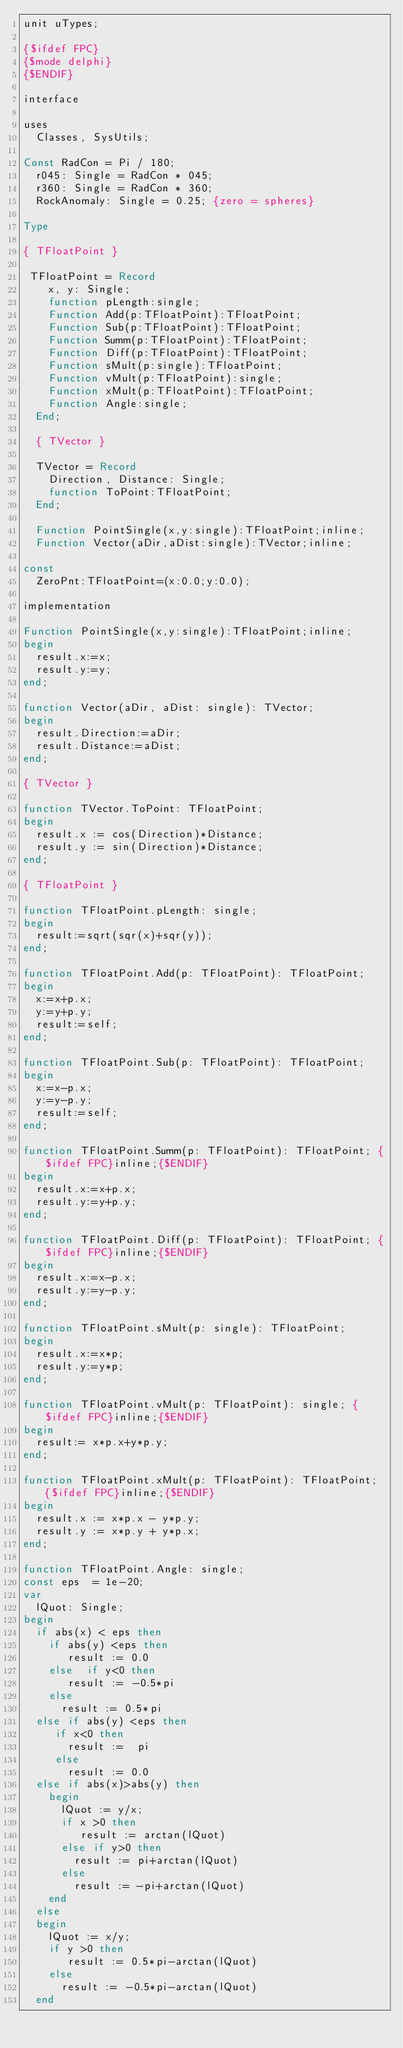Convert code to text. <code><loc_0><loc_0><loc_500><loc_500><_Pascal_>unit uTypes;

{$ifdef FPC}
{$mode delphi}
{$ENDIF}

interface

uses
  Classes, SysUtils;

Const RadCon = Pi / 180;
  r045: Single = RadCon * 045;
  r360: Single = RadCon * 360;
  RockAnomaly: Single = 0.25; {zero = spheres}

Type

{ TFloatPoint }

 TFloatPoint = Record
    x, y: Single;
    function pLength:single;
    Function Add(p:TFloatPoint):TFloatPoint;
    Function Sub(p:TFloatPoint):TFloatPoint;
    Function Summ(p:TFloatPoint):TFloatPoint;
    Function Diff(p:TFloatPoint):TFloatPoint;
    Function sMult(p:single):TFloatPoint;
    Function vMult(p:TFloatPoint):single;
    Function xMult(p:TFloatPoint):TFloatPoint;
    Function Angle:single;
  End;

  { TVector }

  TVector = Record
    Direction, Distance: Single;
    function ToPoint:TFloatPoint;
  End;

  Function PointSingle(x,y:single):TFloatPoint;inline;
  Function Vector(aDir,aDist:single):TVector;inline;

const
  ZeroPnt:TFloatPoint=(x:0.0;y:0.0);

implementation

Function PointSingle(x,y:single):TFloatPoint;inline;
begin
  result.x:=x;
  result.y:=y;
end;

function Vector(aDir, aDist: single): TVector;
begin
  result.Direction:=aDir;
  result.Distance:=aDist;
end;

{ TVector }

function TVector.ToPoint: TFloatPoint;
begin
  result.x := cos(Direction)*Distance;
  result.y := sin(Direction)*Distance;
end;

{ TFloatPoint }

function TFloatPoint.pLength: single;
begin
  result:=sqrt(sqr(x)+sqr(y));
end;

function TFloatPoint.Add(p: TFloatPoint): TFloatPoint;
begin
  x:=x+p.x;
  y:=y+p.y;
  result:=self;
end;

function TFloatPoint.Sub(p: TFloatPoint): TFloatPoint;
begin
  x:=x-p.x;
  y:=y-p.y;
  result:=self;
end;

function TFloatPoint.Summ(p: TFloatPoint): TFloatPoint; {$ifdef FPC}inline;{$ENDIF}
begin
  result.x:=x+p.x;
  result.y:=y+p.y;
end;

function TFloatPoint.Diff(p: TFloatPoint): TFloatPoint; {$ifdef FPC}inline;{$ENDIF}
begin
  result.x:=x-p.x;
  result.y:=y-p.y;
end;

function TFloatPoint.sMult(p: single): TFloatPoint;
begin
  result.x:=x*p;
  result.y:=y*p;
end;

function TFloatPoint.vMult(p: TFloatPoint): single; {$ifdef FPC}inline;{$ENDIF}
begin
  result:= x*p.x+y*p.y;
end;

function TFloatPoint.xMult(p: TFloatPoint): TFloatPoint; {$ifdef FPC}inline;{$ENDIF}
begin
  result.x := x*p.x - y*p.y;
  result.y := x*p.y + y*p.x;
end;

function TFloatPoint.Angle: single;
const eps  = 1e-20;
var
  lQuot: Single;
begin
  if abs(x) < eps then
    if abs(y) <eps then
       result := 0.0
    else  if y<0 then
       result := -0.5*pi
    else
      result := 0.5*pi
  else if abs(y) <eps then
     if x<0 then
       result :=  pi
     else
       result := 0.0
  else if abs(x)>abs(y) then
    begin
      lQuot := y/x;
      if x >0 then
         result := arctan(lQuot)
      else if y>0 then
        result := pi+arctan(lQuot)
      else
        result := -pi+arctan(lQuot)
    end
  else
  begin
    lQuot := x/y;
    if y >0 then
       result := 0.5*pi-arctan(lQuot)
    else
      result := -0.5*pi-arctan(lQuot)
  end
</code> 